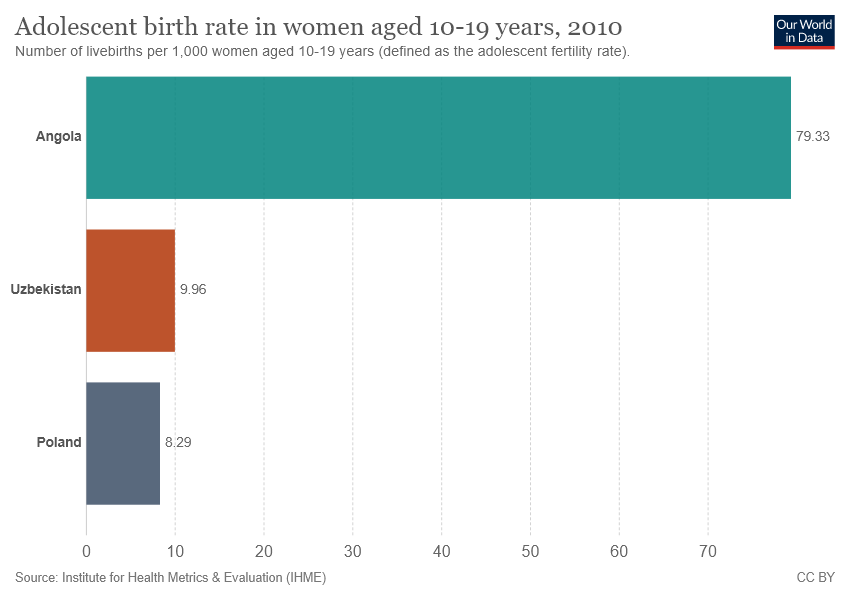Mention a couple of crucial points in this snapshot. The value of the longest bar is 79.33 